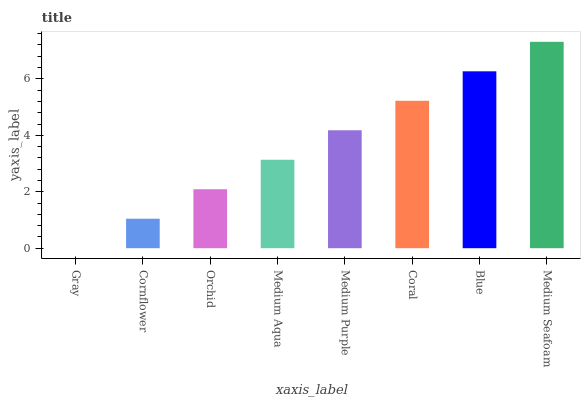Is Cornflower the minimum?
Answer yes or no. No. Is Cornflower the maximum?
Answer yes or no. No. Is Cornflower greater than Gray?
Answer yes or no. Yes. Is Gray less than Cornflower?
Answer yes or no. Yes. Is Gray greater than Cornflower?
Answer yes or no. No. Is Cornflower less than Gray?
Answer yes or no. No. Is Medium Purple the high median?
Answer yes or no. Yes. Is Medium Aqua the low median?
Answer yes or no. Yes. Is Medium Aqua the high median?
Answer yes or no. No. Is Coral the low median?
Answer yes or no. No. 